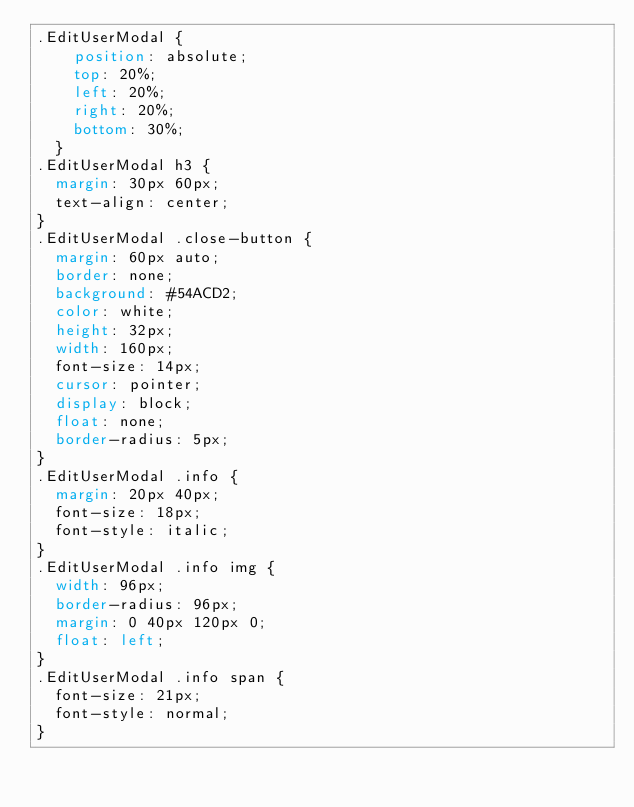<code> <loc_0><loc_0><loc_500><loc_500><_CSS_>.EditUserModal {
    position: absolute;
    top: 20%;
    left: 20%;
    right: 20%;
    bottom: 30%;
  }
.EditUserModal h3 {
  margin: 30px 60px;
  text-align: center;
}
.EditUserModal .close-button {
  margin: 60px auto;
  border: none;
  background: #54ACD2;
  color: white;
  height: 32px;
  width: 160px;
  font-size: 14px;
  cursor: pointer;
  display: block;
  float: none;
  border-radius: 5px;
}
.EditUserModal .info {
  margin: 20px 40px;
  font-size: 18px;
  font-style: italic;
}
.EditUserModal .info img {
  width: 96px;
  border-radius: 96px;
  margin: 0 40px 120px 0;
  float: left;
}
.EditUserModal .info span {
  font-size: 21px;
  font-style: normal;
}</code> 